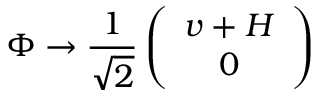Convert formula to latex. <formula><loc_0><loc_0><loc_500><loc_500>\Phi \to \frac { 1 } { \sqrt { 2 } } \left ( \begin{array} { c } { v + H } \\ { 0 } \end{array} \right )</formula> 